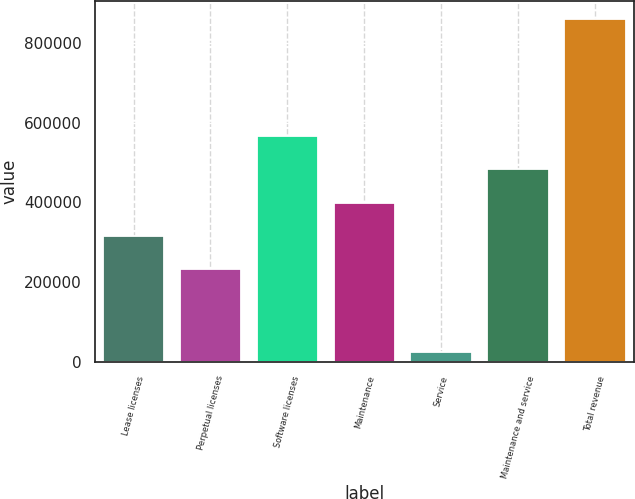<chart> <loc_0><loc_0><loc_500><loc_500><bar_chart><fcel>Lease licenses<fcel>Perpetual licenses<fcel>Software licenses<fcel>Maintenance<fcel>Service<fcel>Maintenance and service<fcel>Total revenue<nl><fcel>315089<fcel>231286<fcel>566498<fcel>398892<fcel>23231<fcel>482695<fcel>861260<nl></chart> 